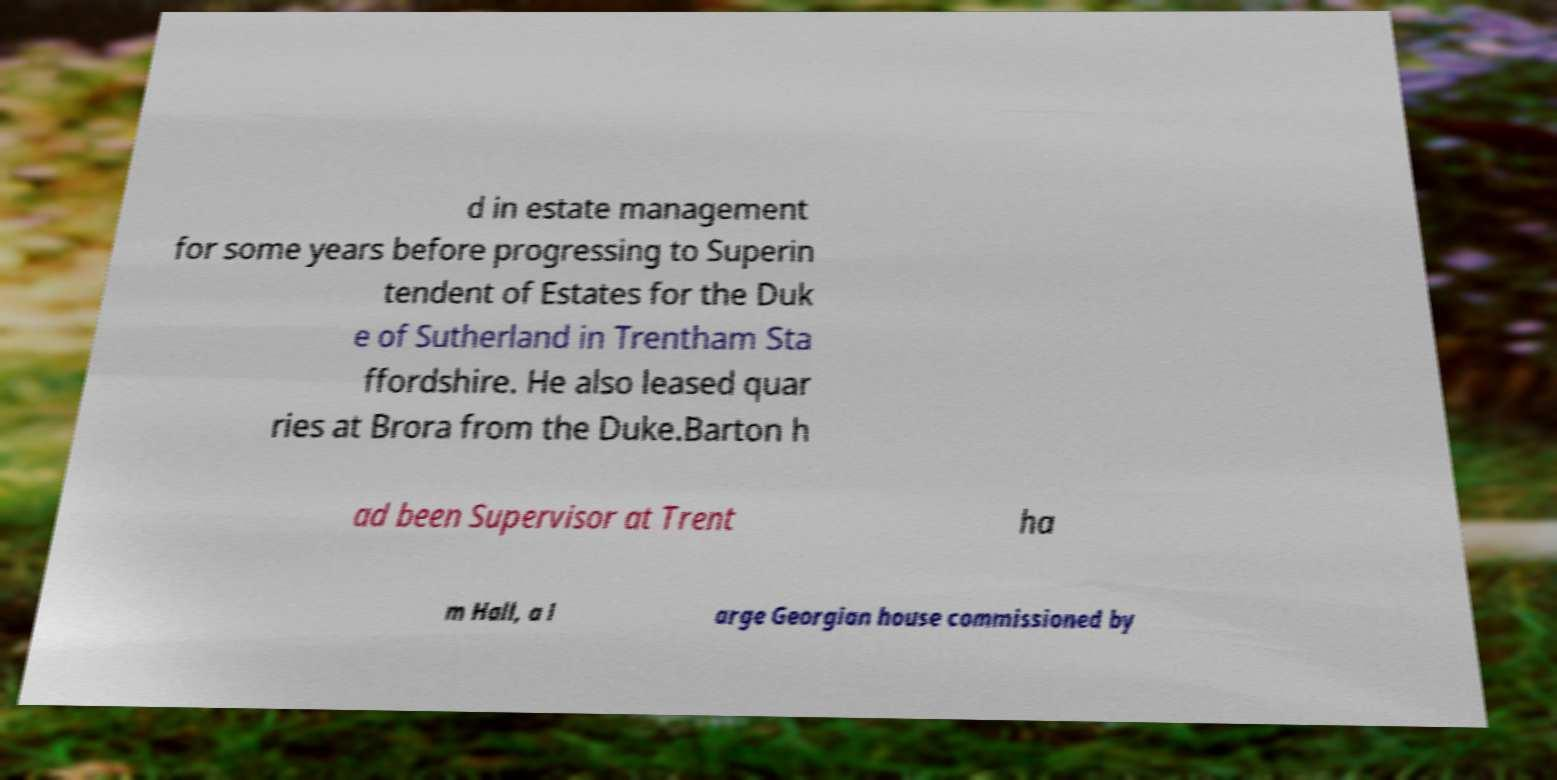Please read and relay the text visible in this image. What does it say? d in estate management for some years before progressing to Superin tendent of Estates for the Duk e of Sutherland in Trentham Sta ffordshire. He also leased quar ries at Brora from the Duke.Barton h ad been Supervisor at Trent ha m Hall, a l arge Georgian house commissioned by 